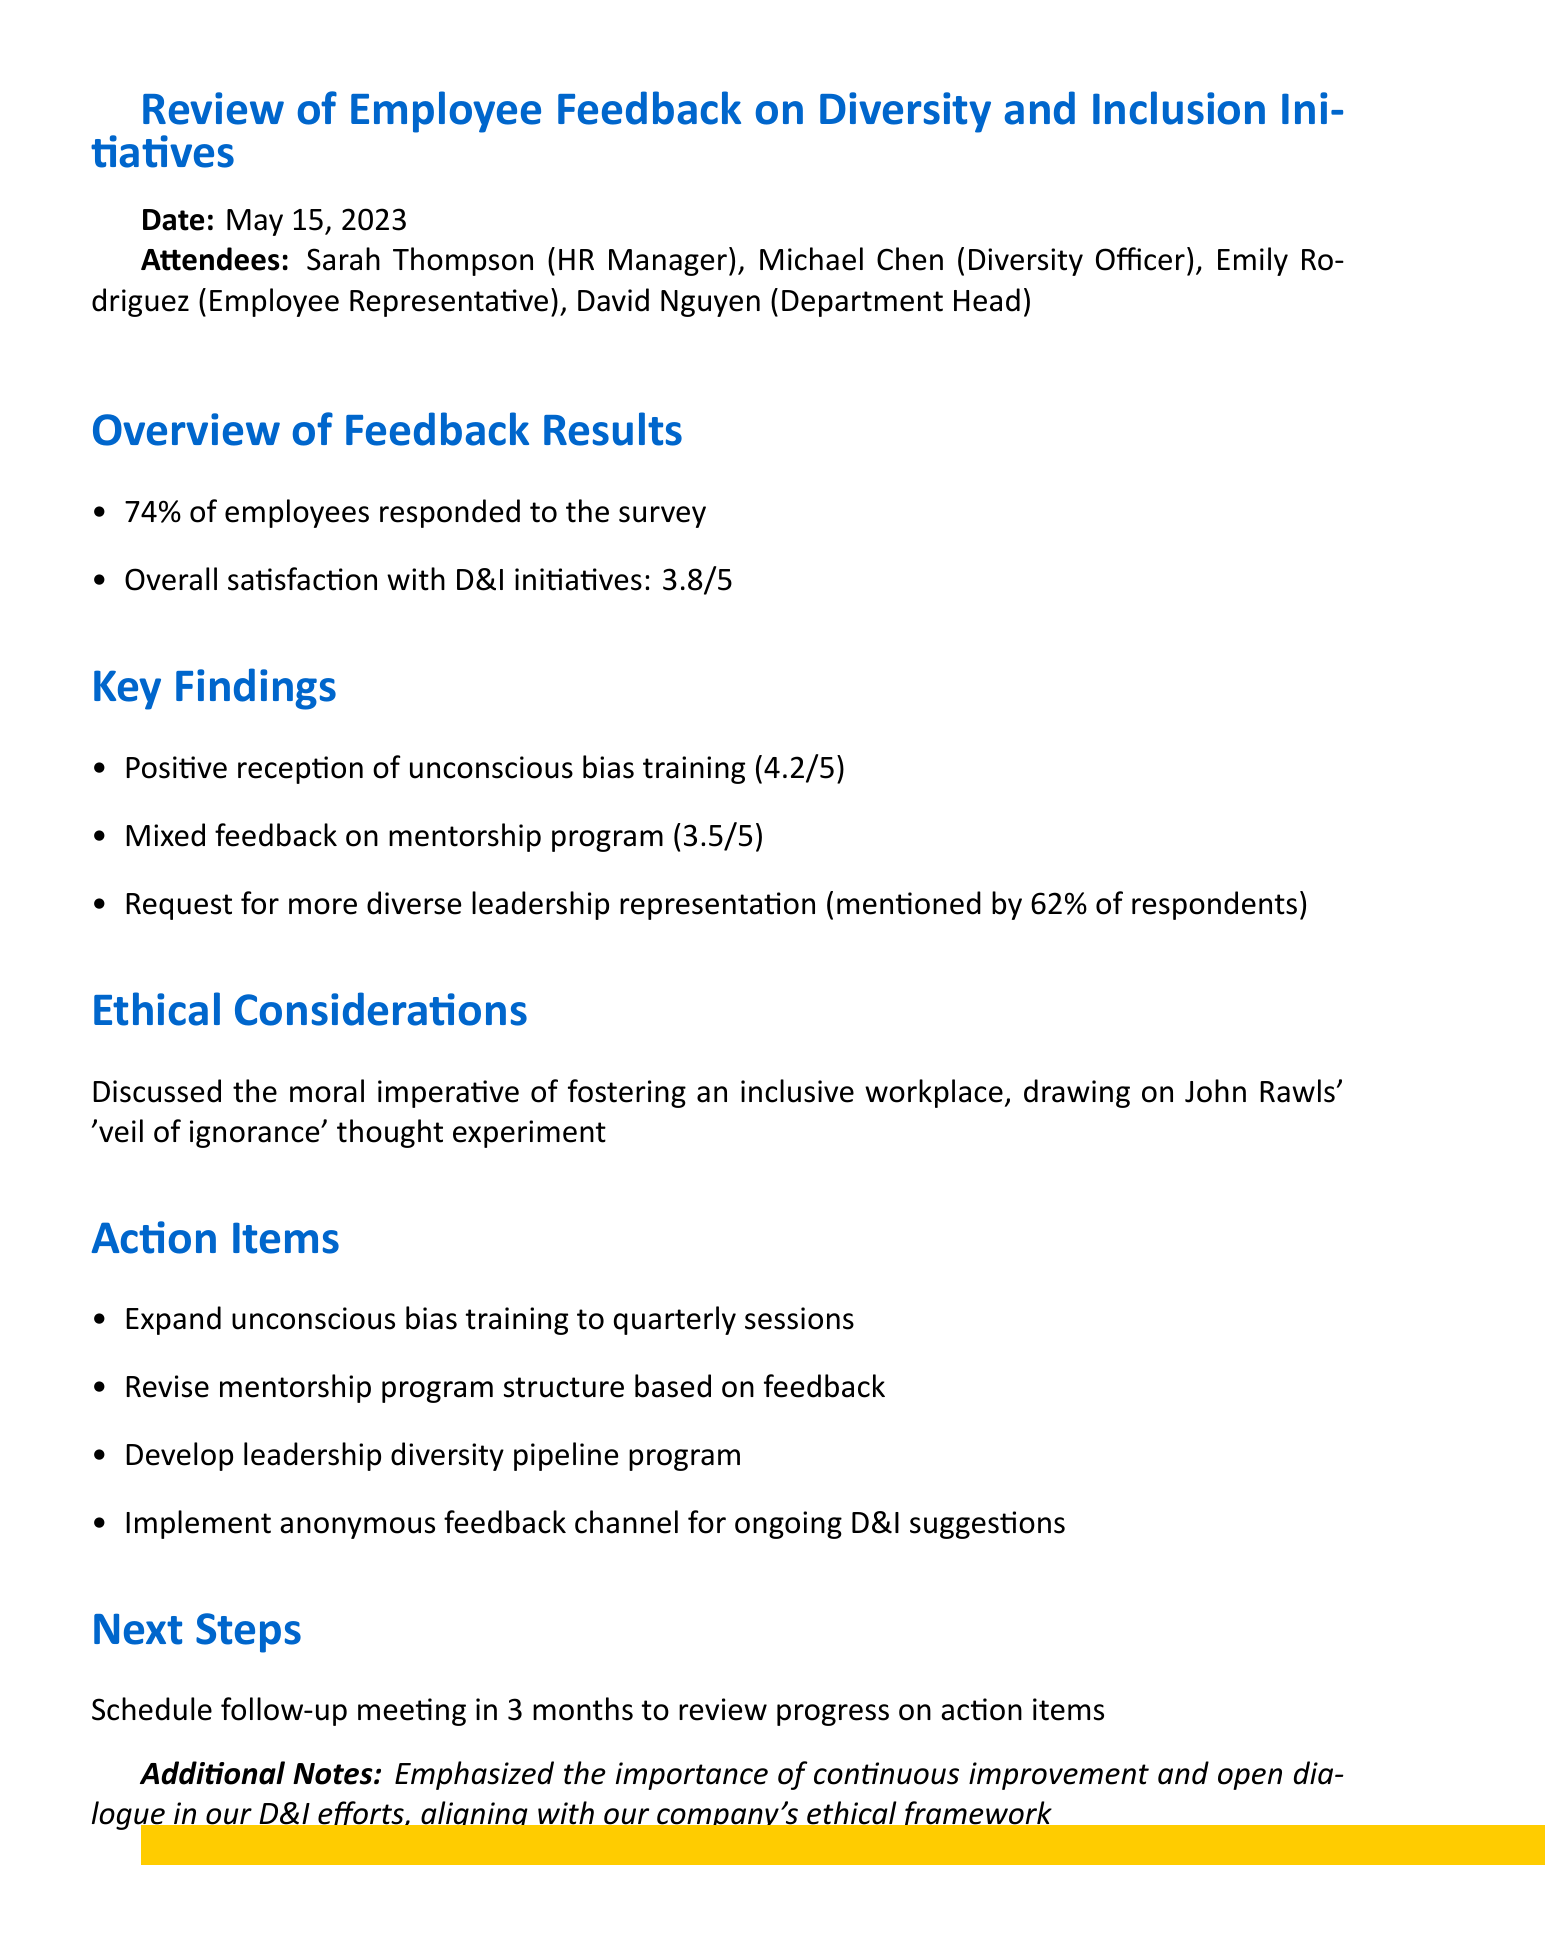What was the overall satisfaction rating with D&I initiatives? The overall satisfaction rating is provided as a score in the document, which is 3.8 out of 5.
Answer: 3.8/5 How many attendees were present at the meeting? The document lists the attendees, providing four names who were present at the meeting.
Answer: 4 Which initiative received the highest rating from employees? The ratings for initiatives are compared in the document, with unconscious bias training receiving the highest rating of 4.2 out of 5.
Answer: Unconscious bias training What percentage of respondents requested more diverse leadership representation? The document specifies that 62% of survey respondents mentioned this need for more diverse leadership.
Answer: 62% What is one of the action items listed for improving the mentorship program? The document details the action items, stating that the mentorship program's structure will be revised based on feedback.
Answer: Revise mentorship program structure Which ethical framework concept was discussed during the meeting? The document refers to John Rawls' 'veil of ignorance' thought experiment as part of the ethical considerations discussed.
Answer: Veil of ignorance When is the next follow-up meeting scheduled? The document mentions a follow-up meeting to be scheduled in three months for reviewing action items.
Answer: 3 months How did the participants emphasize the importance of ongoing dialogue? The document notes an emphasis on continuous improvement and open dialogue as part of their D&I efforts, aligning with their company's ethical framework.
Answer: Continuous improvement and open dialogue 